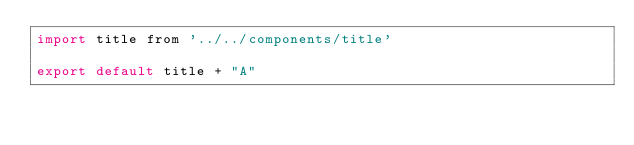<code> <loc_0><loc_0><loc_500><loc_500><_JavaScript_>import title from '../../components/title'

export default title + "A"</code> 